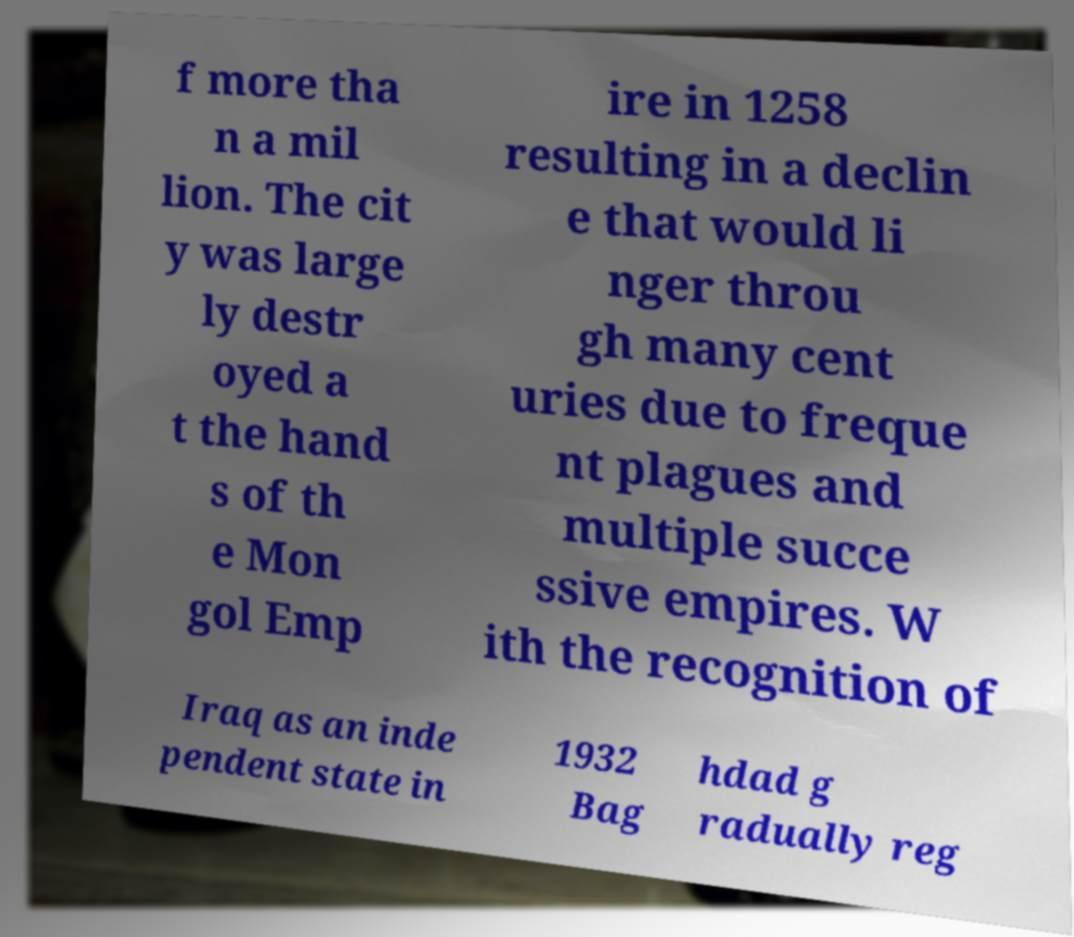Please read and relay the text visible in this image. What does it say? f more tha n a mil lion. The cit y was large ly destr oyed a t the hand s of th e Mon gol Emp ire in 1258 resulting in a declin e that would li nger throu gh many cent uries due to freque nt plagues and multiple succe ssive empires. W ith the recognition of Iraq as an inde pendent state in 1932 Bag hdad g radually reg 